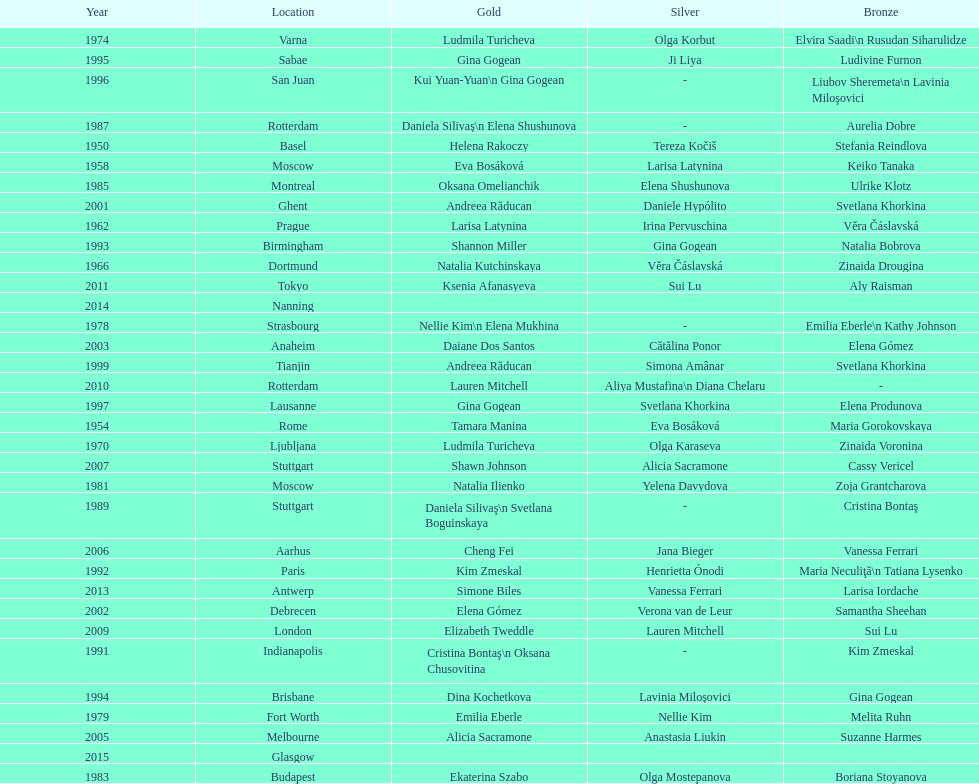How long is the time between the times the championship was held in moscow? 23 years. 